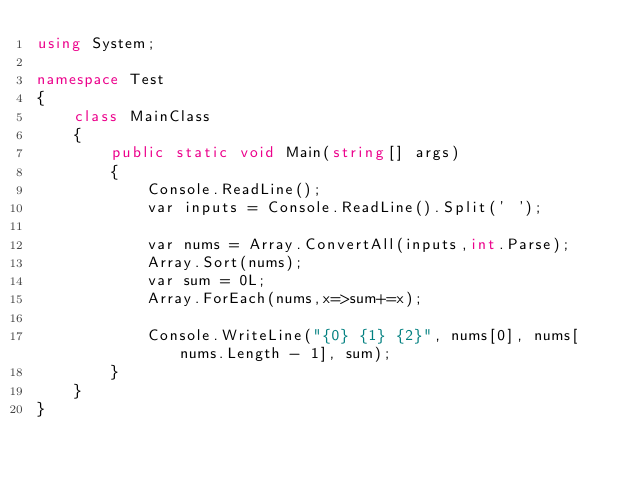Convert code to text. <code><loc_0><loc_0><loc_500><loc_500><_C#_>using System;

namespace Test
{
    class MainClass
    {
        public static void Main(string[] args)
        {
            Console.ReadLine();
            var inputs = Console.ReadLine().Split(' ');

            var nums = Array.ConvertAll(inputs,int.Parse);
            Array.Sort(nums);
            var sum = 0L;
            Array.ForEach(nums,x=>sum+=x);

            Console.WriteLine("{0} {1} {2}", nums[0], nums[nums.Length - 1], sum);
        }
    }
}</code> 